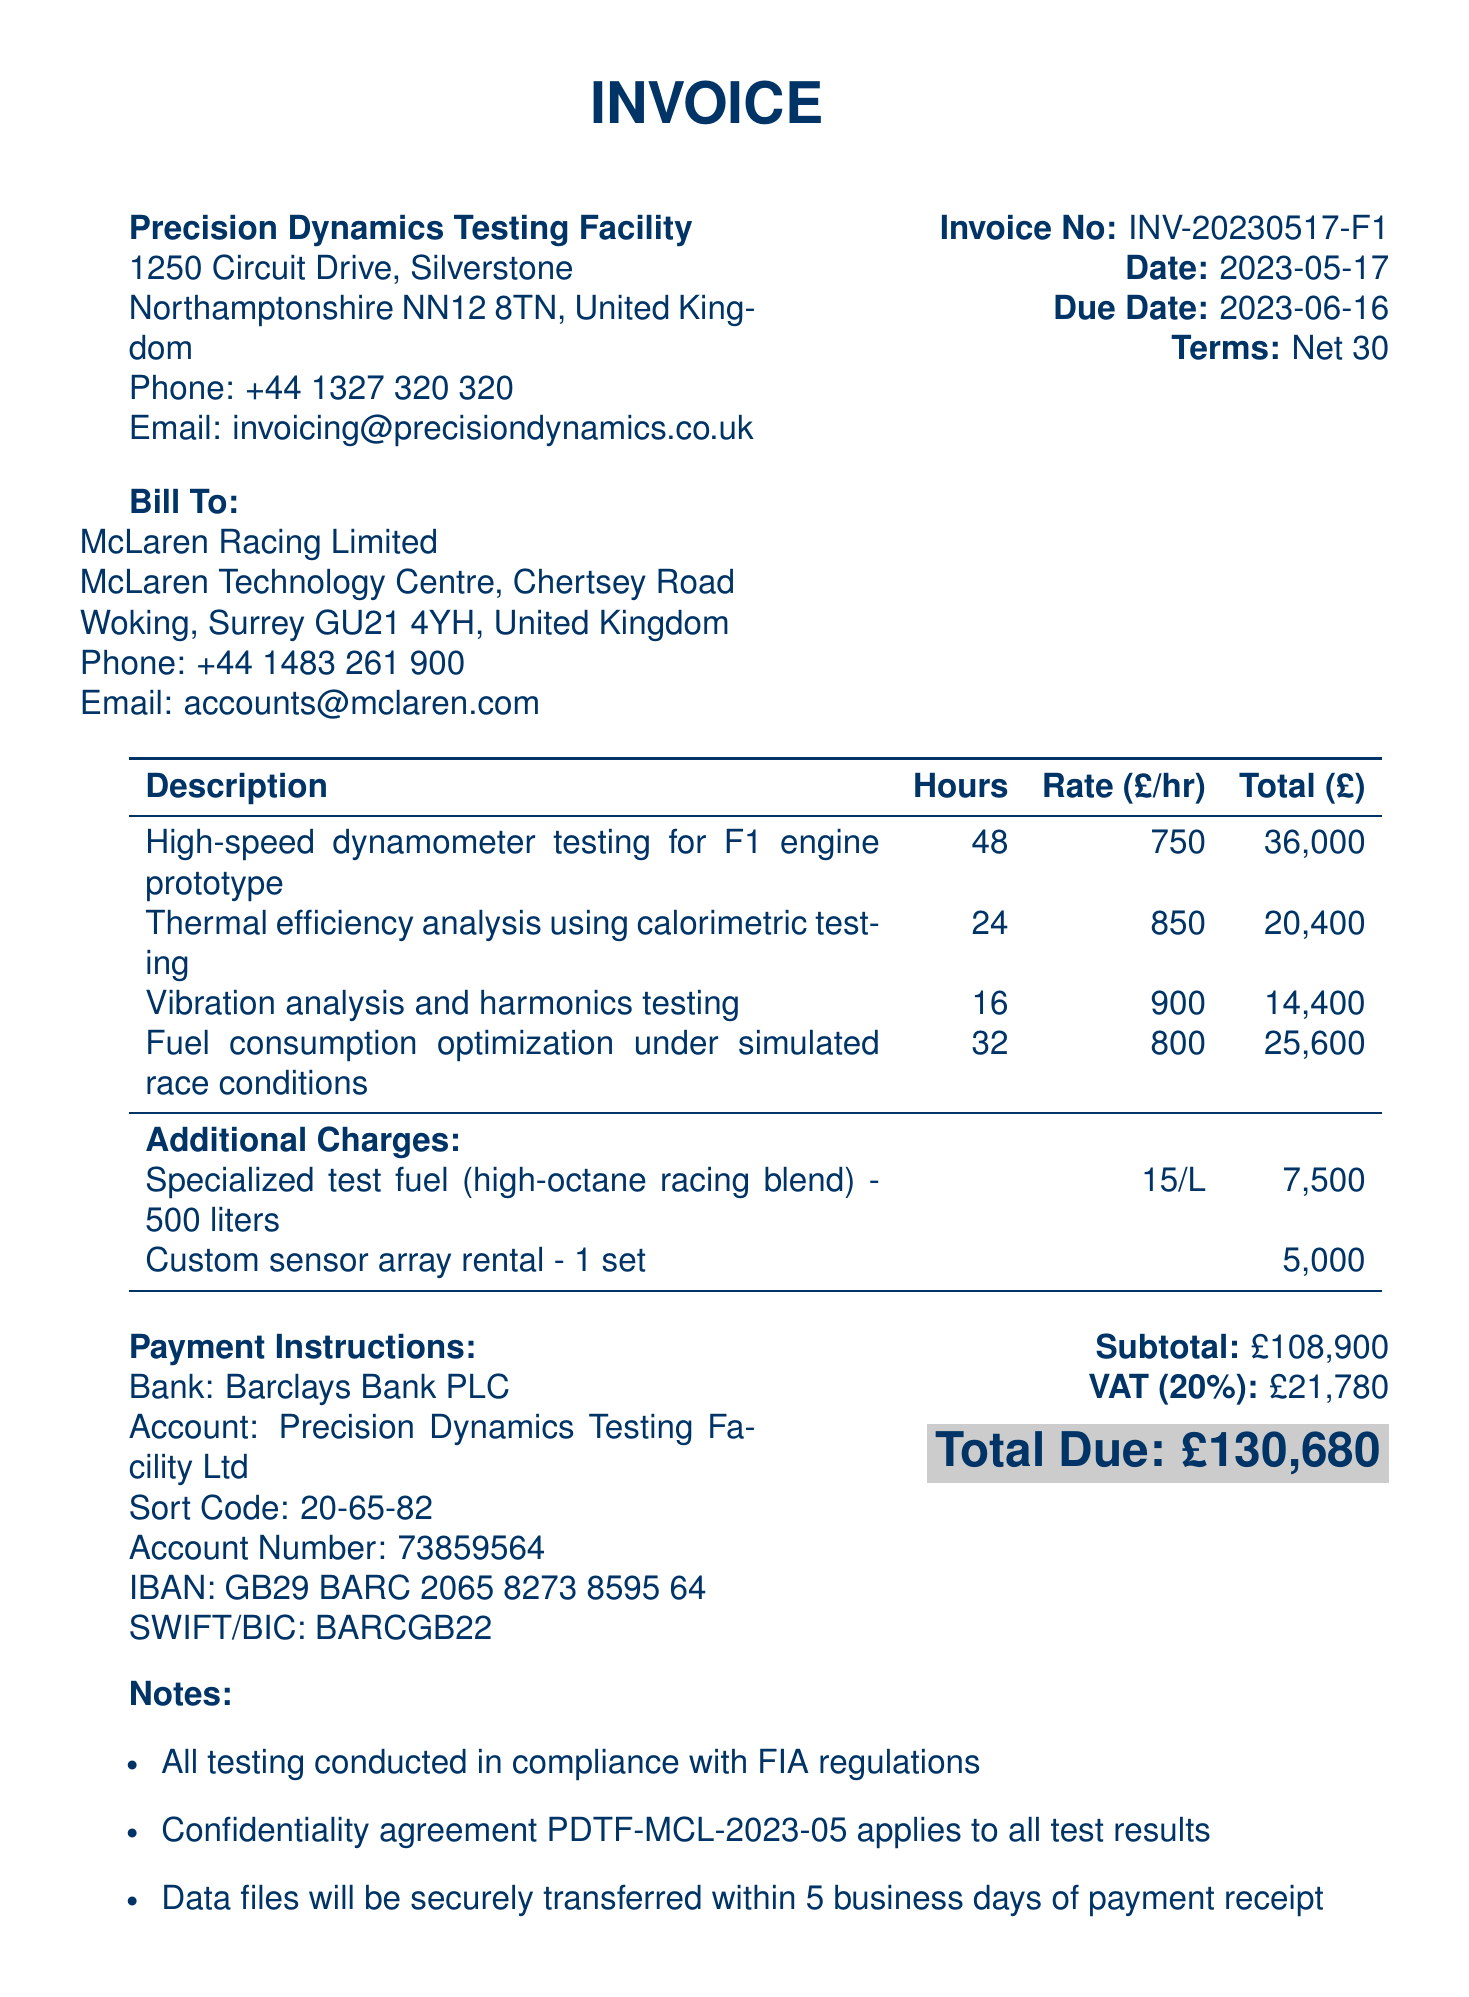what is the invoice number? The invoice number is listed in the document as a specific identifier for the transaction.
Answer: INV-20230517-F1 what is the total amount due? The total amount due is the final figure that includes all services, additional charges, and VAT.
Answer: £130,680 who is the service provider? The service provider is the organization that completed the testing services.
Answer: Precision Dynamics Testing Facility what is the VAT rate? The VAT rate is the percentage applied to the subtotal for tax calculations in the document.
Answer: 20% how many hours were spent on thermal efficiency analysis? This is the number of hours associated with the specific testing service provided.
Answer: 24 calculate the subtotal of services provided. The subtotal is the sum of all services listed, which includes the costs of individual services but excludes VAT and additional charges.
Answer: £108,900 when is the payment due? The due date specifies when payment must be made according to the payment terms.
Answer: 2023-06-16 what is the cost of specialized test fuel? This is the price charged for the additional resource used in the testing.
Answer: £7,500 what are the payment instructions? The payment instructions detail how to make the payment and include bank information.
Answer: Barclays Bank PLC, Precision Dynamics Testing Facility Ltd, Sort Code: 20-65-82, Account Number: 73859564 